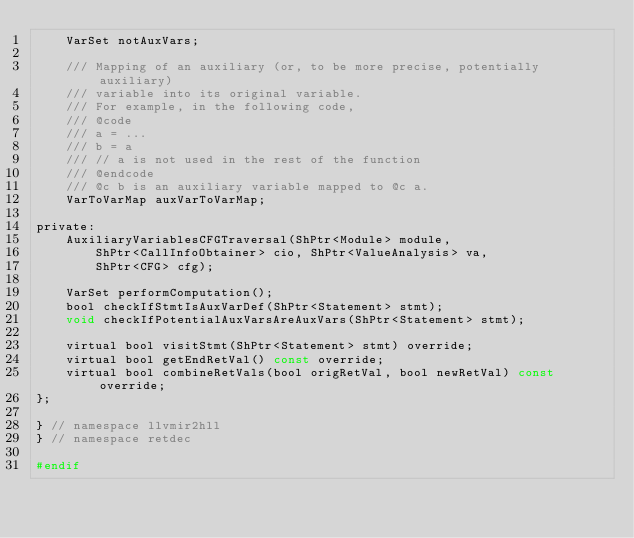Convert code to text. <code><loc_0><loc_0><loc_500><loc_500><_C_>	VarSet notAuxVars;

	/// Mapping of an auxiliary (or, to be more precise, potentially auxiliary)
	/// variable into its original variable.
	/// For example, in the following code,
	/// @code
	/// a = ...
	/// b = a
	/// // a is not used in the rest of the function
	/// @endcode
	/// @c b is an auxiliary variable mapped to @c a.
	VarToVarMap auxVarToVarMap;

private:
	AuxiliaryVariablesCFGTraversal(ShPtr<Module> module,
		ShPtr<CallInfoObtainer> cio, ShPtr<ValueAnalysis> va,
		ShPtr<CFG> cfg);

	VarSet performComputation();
	bool checkIfStmtIsAuxVarDef(ShPtr<Statement> stmt);
	void checkIfPotentialAuxVarsAreAuxVars(ShPtr<Statement> stmt);

	virtual bool visitStmt(ShPtr<Statement> stmt) override;
	virtual bool getEndRetVal() const override;
	virtual bool combineRetVals(bool origRetVal, bool newRetVal) const override;
};

} // namespace llvmir2hll
} // namespace retdec

#endif
</code> 